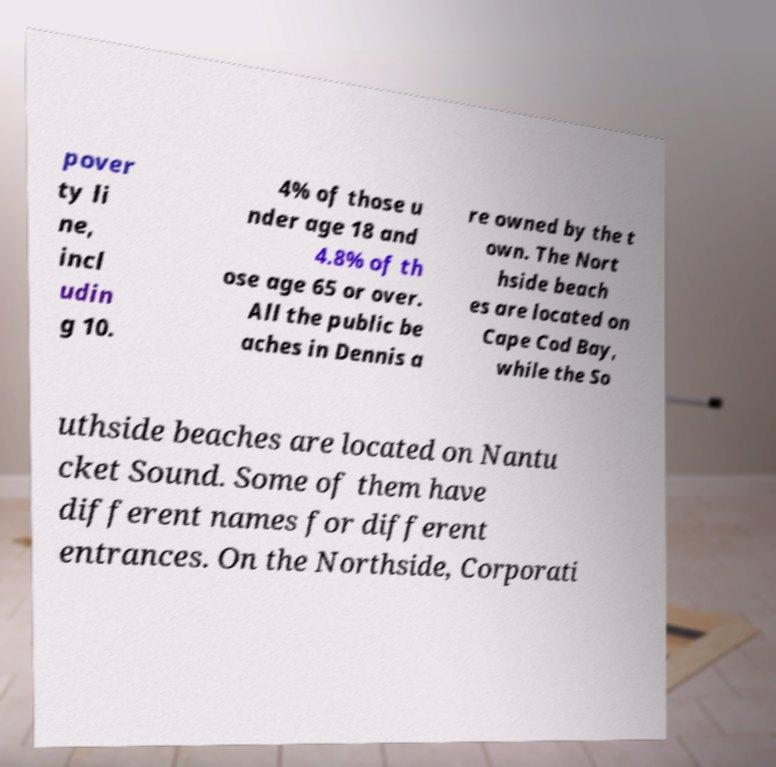Could you assist in decoding the text presented in this image and type it out clearly? pover ty li ne, incl udin g 10. 4% of those u nder age 18 and 4.8% of th ose age 65 or over. All the public be aches in Dennis a re owned by the t own. The Nort hside beach es are located on Cape Cod Bay, while the So uthside beaches are located on Nantu cket Sound. Some of them have different names for different entrances. On the Northside, Corporati 